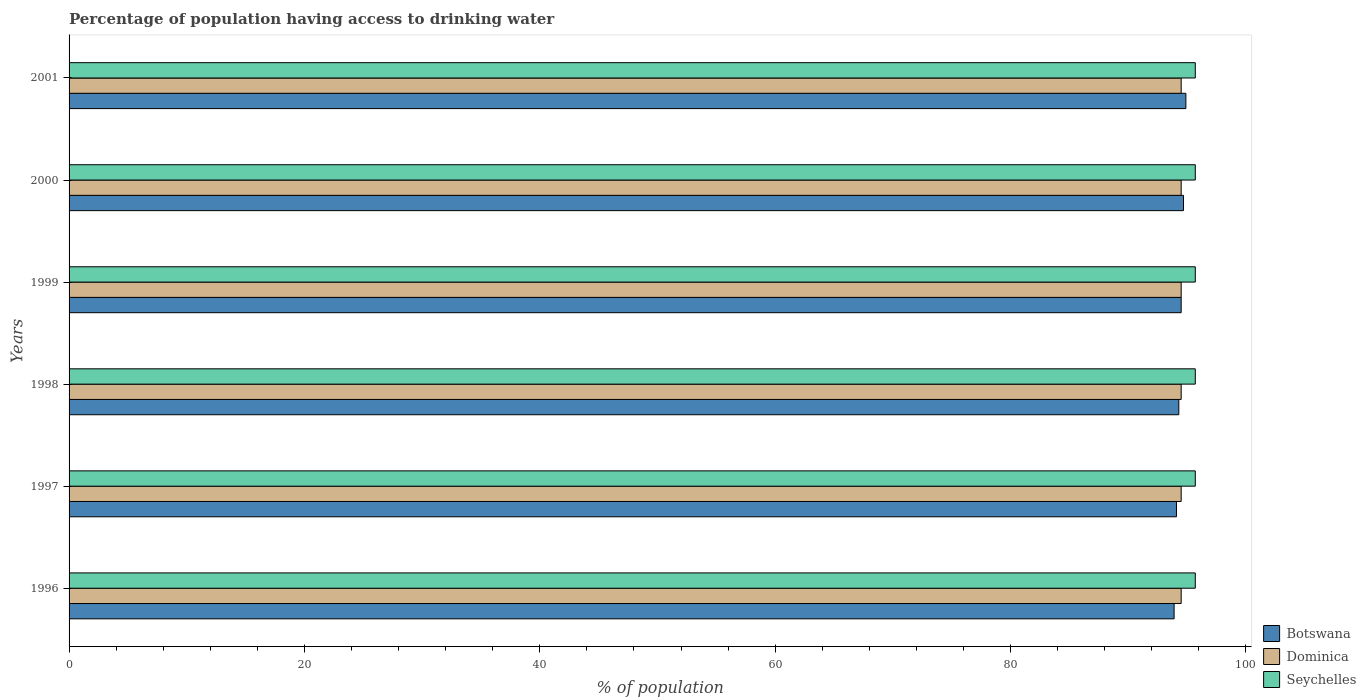How many groups of bars are there?
Your response must be concise. 6. Are the number of bars per tick equal to the number of legend labels?
Make the answer very short. Yes. In how many cases, is the number of bars for a given year not equal to the number of legend labels?
Make the answer very short. 0. What is the percentage of population having access to drinking water in Botswana in 1999?
Provide a short and direct response. 94.5. Across all years, what is the maximum percentage of population having access to drinking water in Seychelles?
Your answer should be very brief. 95.7. Across all years, what is the minimum percentage of population having access to drinking water in Dominica?
Keep it short and to the point. 94.5. In which year was the percentage of population having access to drinking water in Botswana minimum?
Your response must be concise. 1996. What is the total percentage of population having access to drinking water in Dominica in the graph?
Offer a terse response. 567. What is the difference between the percentage of population having access to drinking water in Botswana in 2000 and that in 2001?
Keep it short and to the point. -0.2. What is the difference between the percentage of population having access to drinking water in Seychelles in 1996 and the percentage of population having access to drinking water in Dominica in 1999?
Offer a terse response. 1.2. What is the average percentage of population having access to drinking water in Seychelles per year?
Give a very brief answer. 95.7. In the year 1997, what is the difference between the percentage of population having access to drinking water in Seychelles and percentage of population having access to drinking water in Botswana?
Your response must be concise. 1.6. In how many years, is the percentage of population having access to drinking water in Dominica greater than 80 %?
Your response must be concise. 6. What is the ratio of the percentage of population having access to drinking water in Dominica in 1999 to that in 2001?
Your response must be concise. 1. Is the difference between the percentage of population having access to drinking water in Seychelles in 1999 and 2000 greater than the difference between the percentage of population having access to drinking water in Botswana in 1999 and 2000?
Offer a terse response. Yes. What is the difference between the highest and the second highest percentage of population having access to drinking water in Botswana?
Offer a terse response. 0.2. Is the sum of the percentage of population having access to drinking water in Seychelles in 1999 and 2000 greater than the maximum percentage of population having access to drinking water in Botswana across all years?
Provide a succinct answer. Yes. What does the 3rd bar from the top in 1999 represents?
Your answer should be very brief. Botswana. What does the 2nd bar from the bottom in 2001 represents?
Offer a terse response. Dominica. What is the difference between two consecutive major ticks on the X-axis?
Keep it short and to the point. 20. Are the values on the major ticks of X-axis written in scientific E-notation?
Make the answer very short. No. Does the graph contain any zero values?
Ensure brevity in your answer.  No. Does the graph contain grids?
Offer a terse response. No. Where does the legend appear in the graph?
Provide a succinct answer. Bottom right. How many legend labels are there?
Offer a very short reply. 3. How are the legend labels stacked?
Provide a succinct answer. Vertical. What is the title of the graph?
Keep it short and to the point. Percentage of population having access to drinking water. What is the label or title of the X-axis?
Offer a terse response. % of population. What is the label or title of the Y-axis?
Offer a terse response. Years. What is the % of population of Botswana in 1996?
Provide a short and direct response. 93.9. What is the % of population in Dominica in 1996?
Provide a succinct answer. 94.5. What is the % of population of Seychelles in 1996?
Provide a succinct answer. 95.7. What is the % of population in Botswana in 1997?
Give a very brief answer. 94.1. What is the % of population in Dominica in 1997?
Ensure brevity in your answer.  94.5. What is the % of population of Seychelles in 1997?
Keep it short and to the point. 95.7. What is the % of population of Botswana in 1998?
Your response must be concise. 94.3. What is the % of population of Dominica in 1998?
Offer a terse response. 94.5. What is the % of population in Seychelles in 1998?
Your response must be concise. 95.7. What is the % of population in Botswana in 1999?
Your answer should be very brief. 94.5. What is the % of population in Dominica in 1999?
Offer a very short reply. 94.5. What is the % of population in Seychelles in 1999?
Keep it short and to the point. 95.7. What is the % of population in Botswana in 2000?
Make the answer very short. 94.7. What is the % of population of Dominica in 2000?
Make the answer very short. 94.5. What is the % of population of Seychelles in 2000?
Make the answer very short. 95.7. What is the % of population in Botswana in 2001?
Provide a succinct answer. 94.9. What is the % of population of Dominica in 2001?
Offer a terse response. 94.5. What is the % of population in Seychelles in 2001?
Give a very brief answer. 95.7. Across all years, what is the maximum % of population in Botswana?
Provide a succinct answer. 94.9. Across all years, what is the maximum % of population of Dominica?
Give a very brief answer. 94.5. Across all years, what is the maximum % of population of Seychelles?
Offer a terse response. 95.7. Across all years, what is the minimum % of population in Botswana?
Give a very brief answer. 93.9. Across all years, what is the minimum % of population of Dominica?
Give a very brief answer. 94.5. Across all years, what is the minimum % of population of Seychelles?
Provide a succinct answer. 95.7. What is the total % of population in Botswana in the graph?
Provide a short and direct response. 566.4. What is the total % of population in Dominica in the graph?
Keep it short and to the point. 567. What is the total % of population in Seychelles in the graph?
Your answer should be compact. 574.2. What is the difference between the % of population in Botswana in 1996 and that in 1997?
Offer a terse response. -0.2. What is the difference between the % of population in Seychelles in 1996 and that in 1997?
Provide a succinct answer. 0. What is the difference between the % of population of Seychelles in 1996 and that in 1998?
Give a very brief answer. 0. What is the difference between the % of population in Dominica in 1996 and that in 1999?
Ensure brevity in your answer.  0. What is the difference between the % of population of Seychelles in 1996 and that in 1999?
Give a very brief answer. 0. What is the difference between the % of population in Botswana in 1997 and that in 1999?
Offer a very short reply. -0.4. What is the difference between the % of population in Dominica in 1997 and that in 1999?
Your answer should be compact. 0. What is the difference between the % of population in Seychelles in 1997 and that in 1999?
Provide a succinct answer. 0. What is the difference between the % of population in Botswana in 1997 and that in 2000?
Your response must be concise. -0.6. What is the difference between the % of population of Seychelles in 1997 and that in 2000?
Ensure brevity in your answer.  0. What is the difference between the % of population in Dominica in 1997 and that in 2001?
Ensure brevity in your answer.  0. What is the difference between the % of population of Botswana in 1998 and that in 1999?
Give a very brief answer. -0.2. What is the difference between the % of population in Seychelles in 1998 and that in 1999?
Ensure brevity in your answer.  0. What is the difference between the % of population of Botswana in 1998 and that in 2000?
Offer a terse response. -0.4. What is the difference between the % of population in Seychelles in 1998 and that in 2000?
Keep it short and to the point. 0. What is the difference between the % of population of Botswana in 1998 and that in 2001?
Keep it short and to the point. -0.6. What is the difference between the % of population of Botswana in 1999 and that in 2000?
Keep it short and to the point. -0.2. What is the difference between the % of population of Dominica in 1999 and that in 2000?
Keep it short and to the point. 0. What is the difference between the % of population of Botswana in 1999 and that in 2001?
Your answer should be very brief. -0.4. What is the difference between the % of population of Seychelles in 1999 and that in 2001?
Your response must be concise. 0. What is the difference between the % of population in Botswana in 2000 and that in 2001?
Your answer should be compact. -0.2. What is the difference between the % of population of Botswana in 1996 and the % of population of Seychelles in 1997?
Give a very brief answer. -1.8. What is the difference between the % of population in Botswana in 1996 and the % of population in Dominica in 1998?
Make the answer very short. -0.6. What is the difference between the % of population in Dominica in 1996 and the % of population in Seychelles in 1999?
Make the answer very short. -1.2. What is the difference between the % of population in Botswana in 1996 and the % of population in Dominica in 2000?
Provide a short and direct response. -0.6. What is the difference between the % of population in Botswana in 1997 and the % of population in Dominica in 1998?
Provide a succinct answer. -0.4. What is the difference between the % of population in Dominica in 1997 and the % of population in Seychelles in 1999?
Your response must be concise. -1.2. What is the difference between the % of population in Dominica in 1997 and the % of population in Seychelles in 2000?
Offer a very short reply. -1.2. What is the difference between the % of population in Botswana in 1997 and the % of population in Seychelles in 2001?
Give a very brief answer. -1.6. What is the difference between the % of population of Dominica in 1997 and the % of population of Seychelles in 2001?
Offer a very short reply. -1.2. What is the difference between the % of population of Botswana in 1998 and the % of population of Dominica in 1999?
Your answer should be compact. -0.2. What is the difference between the % of population of Botswana in 1998 and the % of population of Seychelles in 1999?
Your answer should be very brief. -1.4. What is the difference between the % of population in Dominica in 1998 and the % of population in Seychelles in 1999?
Keep it short and to the point. -1.2. What is the difference between the % of population of Botswana in 1998 and the % of population of Dominica in 2000?
Ensure brevity in your answer.  -0.2. What is the difference between the % of population in Botswana in 1998 and the % of population in Dominica in 2001?
Your answer should be compact. -0.2. What is the difference between the % of population in Botswana in 1998 and the % of population in Seychelles in 2001?
Make the answer very short. -1.4. What is the difference between the % of population in Dominica in 1998 and the % of population in Seychelles in 2001?
Keep it short and to the point. -1.2. What is the difference between the % of population in Botswana in 1999 and the % of population in Dominica in 2001?
Provide a succinct answer. 0. What is the difference between the % of population of Botswana in 1999 and the % of population of Seychelles in 2001?
Offer a terse response. -1.2. What is the average % of population of Botswana per year?
Your response must be concise. 94.4. What is the average % of population of Dominica per year?
Ensure brevity in your answer.  94.5. What is the average % of population in Seychelles per year?
Your answer should be very brief. 95.7. In the year 1996, what is the difference between the % of population in Botswana and % of population in Dominica?
Your answer should be compact. -0.6. In the year 1997, what is the difference between the % of population in Botswana and % of population in Dominica?
Your response must be concise. -0.4. In the year 1997, what is the difference between the % of population in Dominica and % of population in Seychelles?
Your answer should be compact. -1.2. In the year 1998, what is the difference between the % of population in Botswana and % of population in Dominica?
Ensure brevity in your answer.  -0.2. In the year 1998, what is the difference between the % of population in Dominica and % of population in Seychelles?
Provide a succinct answer. -1.2. In the year 1999, what is the difference between the % of population of Dominica and % of population of Seychelles?
Offer a very short reply. -1.2. In the year 2000, what is the difference between the % of population of Botswana and % of population of Dominica?
Provide a succinct answer. 0.2. In the year 2000, what is the difference between the % of population in Botswana and % of population in Seychelles?
Ensure brevity in your answer.  -1. In the year 2000, what is the difference between the % of population in Dominica and % of population in Seychelles?
Give a very brief answer. -1.2. What is the ratio of the % of population in Botswana in 1996 to that in 1997?
Your answer should be very brief. 1. What is the ratio of the % of population of Seychelles in 1996 to that in 1998?
Your answer should be very brief. 1. What is the ratio of the % of population of Botswana in 1996 to that in 1999?
Your response must be concise. 0.99. What is the ratio of the % of population in Dominica in 1996 to that in 1999?
Give a very brief answer. 1. What is the ratio of the % of population in Seychelles in 1996 to that in 1999?
Give a very brief answer. 1. What is the ratio of the % of population of Botswana in 1996 to that in 2000?
Provide a short and direct response. 0.99. What is the ratio of the % of population of Botswana in 1997 to that in 1998?
Your answer should be very brief. 1. What is the ratio of the % of population of Botswana in 1997 to that in 1999?
Provide a short and direct response. 1. What is the ratio of the % of population of Dominica in 1997 to that in 1999?
Ensure brevity in your answer.  1. What is the ratio of the % of population in Botswana in 1997 to that in 2000?
Ensure brevity in your answer.  0.99. What is the ratio of the % of population in Dominica in 1997 to that in 2001?
Your answer should be compact. 1. What is the ratio of the % of population of Seychelles in 1997 to that in 2001?
Ensure brevity in your answer.  1. What is the ratio of the % of population in Dominica in 1998 to that in 1999?
Give a very brief answer. 1. What is the ratio of the % of population of Dominica in 1998 to that in 2000?
Your answer should be compact. 1. What is the ratio of the % of population of Botswana in 1998 to that in 2001?
Offer a terse response. 0.99. What is the ratio of the % of population in Dominica in 1998 to that in 2001?
Provide a succinct answer. 1. What is the ratio of the % of population in Seychelles in 1998 to that in 2001?
Your response must be concise. 1. What is the ratio of the % of population in Botswana in 1999 to that in 2000?
Your answer should be very brief. 1. What is the ratio of the % of population in Seychelles in 1999 to that in 2000?
Make the answer very short. 1. What is the ratio of the % of population of Botswana in 1999 to that in 2001?
Your answer should be very brief. 1. What is the ratio of the % of population in Dominica in 1999 to that in 2001?
Offer a terse response. 1. What is the ratio of the % of population in Dominica in 2000 to that in 2001?
Your answer should be compact. 1. What is the difference between the highest and the second highest % of population in Botswana?
Make the answer very short. 0.2. What is the difference between the highest and the second highest % of population of Seychelles?
Give a very brief answer. 0. What is the difference between the highest and the lowest % of population of Seychelles?
Offer a very short reply. 0. 